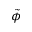<formula> <loc_0><loc_0><loc_500><loc_500>\tilde { \phi }</formula> 